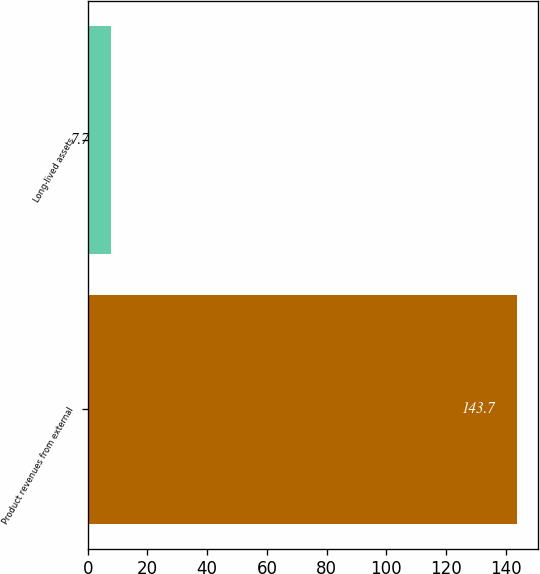<chart> <loc_0><loc_0><loc_500><loc_500><bar_chart><fcel>Product revenues from external<fcel>Long-lived assets<nl><fcel>143.7<fcel>7.7<nl></chart> 